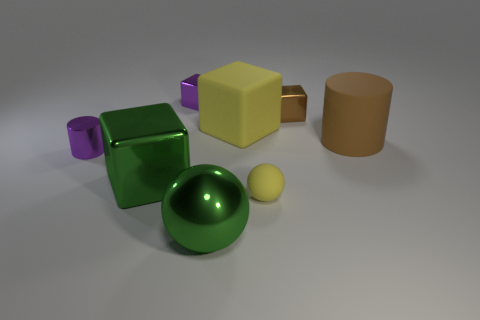There is a purple shiny object that is behind the small purple cylinder; is its shape the same as the big brown thing?
Offer a terse response. No. What is the color of the ball that is the same material as the large green cube?
Provide a succinct answer. Green. There is a tiny block that is to the right of the small metal object that is behind the small brown block; is there a small brown shiny thing that is left of it?
Ensure brevity in your answer.  No. What is the shape of the tiny yellow object?
Give a very brief answer. Sphere. Is the number of large yellow matte objects in front of the small brown cube less than the number of purple matte cylinders?
Offer a terse response. No. Are there any metal things of the same shape as the large brown matte thing?
Offer a terse response. Yes. There is a metal object that is the same size as the green cube; what shape is it?
Give a very brief answer. Sphere. What number of objects are metallic things or matte cubes?
Your answer should be compact. 6. Are there any cyan matte spheres?
Keep it short and to the point. No. Are there fewer tiny purple matte cubes than green metallic objects?
Offer a terse response. Yes. 